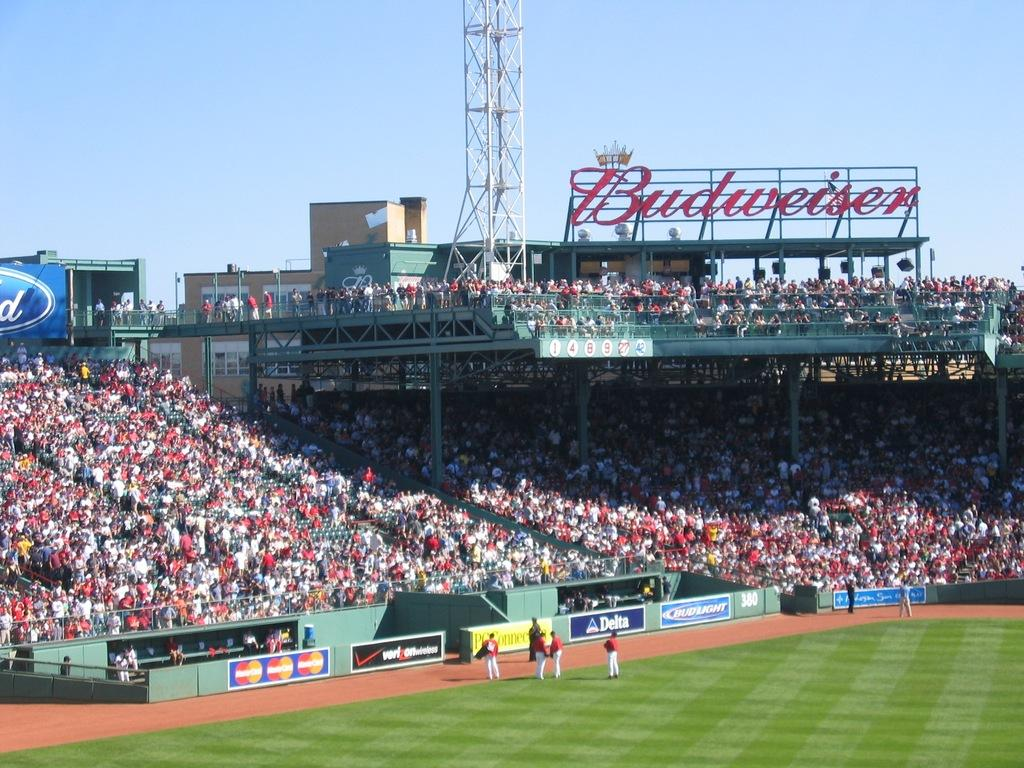<image>
Describe the image concisely. Baseball stadium with the word Budweisier hanging on the top. 